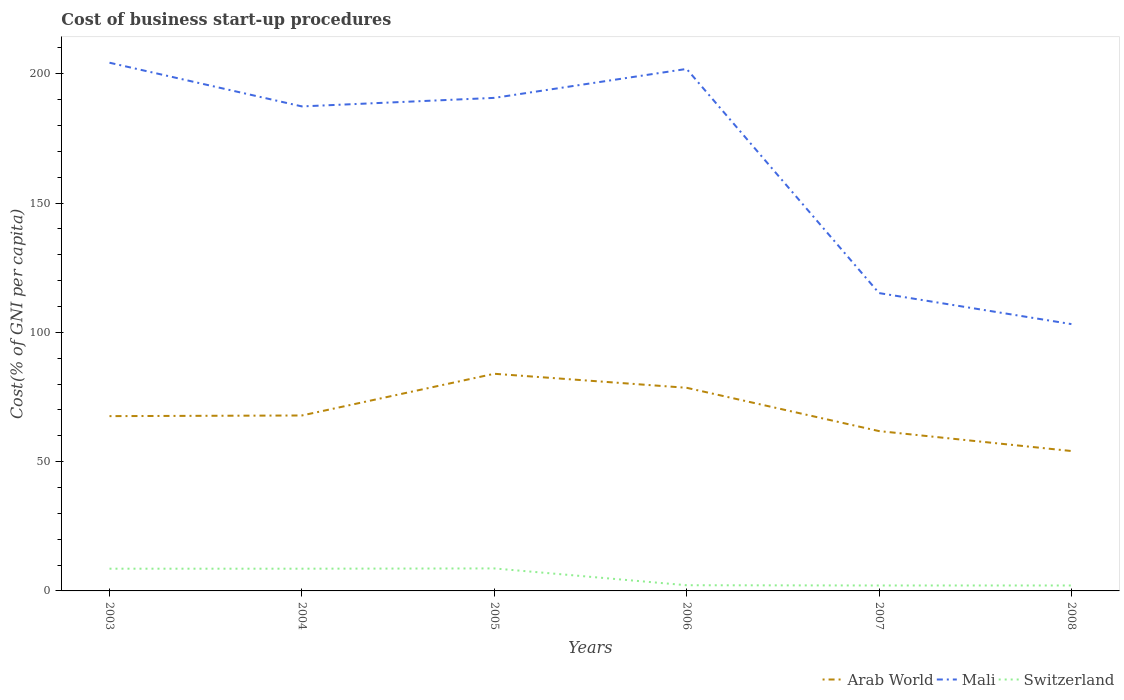How many different coloured lines are there?
Provide a short and direct response. 3. Across all years, what is the maximum cost of business start-up procedures in Arab World?
Give a very brief answer. 54.11. In which year was the cost of business start-up procedures in Arab World maximum?
Your answer should be very brief. 2008. What is the difference between the highest and the second highest cost of business start-up procedures in Switzerland?
Ensure brevity in your answer.  6.6. Is the cost of business start-up procedures in Arab World strictly greater than the cost of business start-up procedures in Mali over the years?
Provide a succinct answer. Yes. How many lines are there?
Provide a short and direct response. 3. Are the values on the major ticks of Y-axis written in scientific E-notation?
Offer a very short reply. No. Does the graph contain any zero values?
Your answer should be compact. No. Does the graph contain grids?
Provide a short and direct response. No. How are the legend labels stacked?
Offer a very short reply. Horizontal. What is the title of the graph?
Your response must be concise. Cost of business start-up procedures. What is the label or title of the Y-axis?
Keep it short and to the point. Cost(% of GNI per capita). What is the Cost(% of GNI per capita) in Arab World in 2003?
Ensure brevity in your answer.  67.61. What is the Cost(% of GNI per capita) in Mali in 2003?
Give a very brief answer. 204.3. What is the Cost(% of GNI per capita) of Switzerland in 2003?
Provide a succinct answer. 8.6. What is the Cost(% of GNI per capita) in Arab World in 2004?
Your response must be concise. 67.86. What is the Cost(% of GNI per capita) in Mali in 2004?
Provide a short and direct response. 187.4. What is the Cost(% of GNI per capita) of Arab World in 2005?
Your response must be concise. 83.99. What is the Cost(% of GNI per capita) of Mali in 2005?
Provide a short and direct response. 190.7. What is the Cost(% of GNI per capita) in Arab World in 2006?
Keep it short and to the point. 78.57. What is the Cost(% of GNI per capita) of Mali in 2006?
Your answer should be compact. 201.9. What is the Cost(% of GNI per capita) in Arab World in 2007?
Provide a succinct answer. 61.82. What is the Cost(% of GNI per capita) in Mali in 2007?
Offer a very short reply. 115.2. What is the Cost(% of GNI per capita) of Arab World in 2008?
Ensure brevity in your answer.  54.11. What is the Cost(% of GNI per capita) of Mali in 2008?
Offer a terse response. 103.2. What is the Cost(% of GNI per capita) in Switzerland in 2008?
Offer a terse response. 2.1. Across all years, what is the maximum Cost(% of GNI per capita) in Arab World?
Make the answer very short. 83.99. Across all years, what is the maximum Cost(% of GNI per capita) of Mali?
Offer a very short reply. 204.3. Across all years, what is the minimum Cost(% of GNI per capita) of Arab World?
Give a very brief answer. 54.11. Across all years, what is the minimum Cost(% of GNI per capita) of Mali?
Ensure brevity in your answer.  103.2. What is the total Cost(% of GNI per capita) of Arab World in the graph?
Offer a very short reply. 413.95. What is the total Cost(% of GNI per capita) in Mali in the graph?
Provide a succinct answer. 1002.7. What is the total Cost(% of GNI per capita) in Switzerland in the graph?
Provide a short and direct response. 32.3. What is the difference between the Cost(% of GNI per capita) in Arab World in 2003 and that in 2004?
Your answer should be very brief. -0.25. What is the difference between the Cost(% of GNI per capita) of Arab World in 2003 and that in 2005?
Provide a short and direct response. -16.38. What is the difference between the Cost(% of GNI per capita) in Arab World in 2003 and that in 2006?
Your answer should be very brief. -10.96. What is the difference between the Cost(% of GNI per capita) in Arab World in 2003 and that in 2007?
Give a very brief answer. 5.79. What is the difference between the Cost(% of GNI per capita) of Mali in 2003 and that in 2007?
Give a very brief answer. 89.1. What is the difference between the Cost(% of GNI per capita) of Switzerland in 2003 and that in 2007?
Provide a succinct answer. 6.5. What is the difference between the Cost(% of GNI per capita) in Arab World in 2003 and that in 2008?
Your answer should be compact. 13.5. What is the difference between the Cost(% of GNI per capita) in Mali in 2003 and that in 2008?
Make the answer very short. 101.1. What is the difference between the Cost(% of GNI per capita) of Arab World in 2004 and that in 2005?
Your answer should be compact. -16.13. What is the difference between the Cost(% of GNI per capita) of Mali in 2004 and that in 2005?
Make the answer very short. -3.3. What is the difference between the Cost(% of GNI per capita) in Switzerland in 2004 and that in 2005?
Make the answer very short. -0.1. What is the difference between the Cost(% of GNI per capita) of Arab World in 2004 and that in 2006?
Keep it short and to the point. -10.71. What is the difference between the Cost(% of GNI per capita) of Arab World in 2004 and that in 2007?
Give a very brief answer. 6.04. What is the difference between the Cost(% of GNI per capita) in Mali in 2004 and that in 2007?
Ensure brevity in your answer.  72.2. What is the difference between the Cost(% of GNI per capita) in Arab World in 2004 and that in 2008?
Keep it short and to the point. 13.75. What is the difference between the Cost(% of GNI per capita) in Mali in 2004 and that in 2008?
Provide a succinct answer. 84.2. What is the difference between the Cost(% of GNI per capita) in Arab World in 2005 and that in 2006?
Provide a succinct answer. 5.42. What is the difference between the Cost(% of GNI per capita) of Mali in 2005 and that in 2006?
Provide a short and direct response. -11.2. What is the difference between the Cost(% of GNI per capita) in Switzerland in 2005 and that in 2006?
Provide a short and direct response. 6.5. What is the difference between the Cost(% of GNI per capita) in Arab World in 2005 and that in 2007?
Keep it short and to the point. 22.17. What is the difference between the Cost(% of GNI per capita) in Mali in 2005 and that in 2007?
Offer a very short reply. 75.5. What is the difference between the Cost(% of GNI per capita) in Switzerland in 2005 and that in 2007?
Make the answer very short. 6.6. What is the difference between the Cost(% of GNI per capita) of Arab World in 2005 and that in 2008?
Make the answer very short. 29.88. What is the difference between the Cost(% of GNI per capita) in Mali in 2005 and that in 2008?
Make the answer very short. 87.5. What is the difference between the Cost(% of GNI per capita) in Arab World in 2006 and that in 2007?
Your answer should be very brief. 16.75. What is the difference between the Cost(% of GNI per capita) of Mali in 2006 and that in 2007?
Provide a short and direct response. 86.7. What is the difference between the Cost(% of GNI per capita) of Switzerland in 2006 and that in 2007?
Your response must be concise. 0.1. What is the difference between the Cost(% of GNI per capita) of Arab World in 2006 and that in 2008?
Your answer should be compact. 24.46. What is the difference between the Cost(% of GNI per capita) of Mali in 2006 and that in 2008?
Your answer should be compact. 98.7. What is the difference between the Cost(% of GNI per capita) in Switzerland in 2006 and that in 2008?
Keep it short and to the point. 0.1. What is the difference between the Cost(% of GNI per capita) in Arab World in 2007 and that in 2008?
Make the answer very short. 7.71. What is the difference between the Cost(% of GNI per capita) of Mali in 2007 and that in 2008?
Your answer should be compact. 12. What is the difference between the Cost(% of GNI per capita) of Switzerland in 2007 and that in 2008?
Make the answer very short. 0. What is the difference between the Cost(% of GNI per capita) of Arab World in 2003 and the Cost(% of GNI per capita) of Mali in 2004?
Offer a terse response. -119.79. What is the difference between the Cost(% of GNI per capita) of Arab World in 2003 and the Cost(% of GNI per capita) of Switzerland in 2004?
Your answer should be compact. 59.01. What is the difference between the Cost(% of GNI per capita) of Mali in 2003 and the Cost(% of GNI per capita) of Switzerland in 2004?
Your response must be concise. 195.7. What is the difference between the Cost(% of GNI per capita) in Arab World in 2003 and the Cost(% of GNI per capita) in Mali in 2005?
Make the answer very short. -123.09. What is the difference between the Cost(% of GNI per capita) of Arab World in 2003 and the Cost(% of GNI per capita) of Switzerland in 2005?
Offer a terse response. 58.91. What is the difference between the Cost(% of GNI per capita) in Mali in 2003 and the Cost(% of GNI per capita) in Switzerland in 2005?
Keep it short and to the point. 195.6. What is the difference between the Cost(% of GNI per capita) in Arab World in 2003 and the Cost(% of GNI per capita) in Mali in 2006?
Your response must be concise. -134.29. What is the difference between the Cost(% of GNI per capita) in Arab World in 2003 and the Cost(% of GNI per capita) in Switzerland in 2006?
Ensure brevity in your answer.  65.41. What is the difference between the Cost(% of GNI per capita) in Mali in 2003 and the Cost(% of GNI per capita) in Switzerland in 2006?
Your answer should be compact. 202.1. What is the difference between the Cost(% of GNI per capita) of Arab World in 2003 and the Cost(% of GNI per capita) of Mali in 2007?
Your answer should be very brief. -47.59. What is the difference between the Cost(% of GNI per capita) in Arab World in 2003 and the Cost(% of GNI per capita) in Switzerland in 2007?
Keep it short and to the point. 65.51. What is the difference between the Cost(% of GNI per capita) of Mali in 2003 and the Cost(% of GNI per capita) of Switzerland in 2007?
Your answer should be very brief. 202.2. What is the difference between the Cost(% of GNI per capita) in Arab World in 2003 and the Cost(% of GNI per capita) in Mali in 2008?
Keep it short and to the point. -35.59. What is the difference between the Cost(% of GNI per capita) in Arab World in 2003 and the Cost(% of GNI per capita) in Switzerland in 2008?
Make the answer very short. 65.51. What is the difference between the Cost(% of GNI per capita) in Mali in 2003 and the Cost(% of GNI per capita) in Switzerland in 2008?
Offer a terse response. 202.2. What is the difference between the Cost(% of GNI per capita) in Arab World in 2004 and the Cost(% of GNI per capita) in Mali in 2005?
Your response must be concise. -122.84. What is the difference between the Cost(% of GNI per capita) in Arab World in 2004 and the Cost(% of GNI per capita) in Switzerland in 2005?
Keep it short and to the point. 59.16. What is the difference between the Cost(% of GNI per capita) of Mali in 2004 and the Cost(% of GNI per capita) of Switzerland in 2005?
Keep it short and to the point. 178.7. What is the difference between the Cost(% of GNI per capita) in Arab World in 2004 and the Cost(% of GNI per capita) in Mali in 2006?
Offer a terse response. -134.04. What is the difference between the Cost(% of GNI per capita) of Arab World in 2004 and the Cost(% of GNI per capita) of Switzerland in 2006?
Offer a very short reply. 65.66. What is the difference between the Cost(% of GNI per capita) in Mali in 2004 and the Cost(% of GNI per capita) in Switzerland in 2006?
Provide a succinct answer. 185.2. What is the difference between the Cost(% of GNI per capita) of Arab World in 2004 and the Cost(% of GNI per capita) of Mali in 2007?
Your response must be concise. -47.34. What is the difference between the Cost(% of GNI per capita) of Arab World in 2004 and the Cost(% of GNI per capita) of Switzerland in 2007?
Provide a succinct answer. 65.76. What is the difference between the Cost(% of GNI per capita) in Mali in 2004 and the Cost(% of GNI per capita) in Switzerland in 2007?
Provide a short and direct response. 185.3. What is the difference between the Cost(% of GNI per capita) of Arab World in 2004 and the Cost(% of GNI per capita) of Mali in 2008?
Give a very brief answer. -35.34. What is the difference between the Cost(% of GNI per capita) in Arab World in 2004 and the Cost(% of GNI per capita) in Switzerland in 2008?
Give a very brief answer. 65.76. What is the difference between the Cost(% of GNI per capita) in Mali in 2004 and the Cost(% of GNI per capita) in Switzerland in 2008?
Offer a very short reply. 185.3. What is the difference between the Cost(% of GNI per capita) of Arab World in 2005 and the Cost(% of GNI per capita) of Mali in 2006?
Offer a terse response. -117.91. What is the difference between the Cost(% of GNI per capita) in Arab World in 2005 and the Cost(% of GNI per capita) in Switzerland in 2006?
Provide a succinct answer. 81.79. What is the difference between the Cost(% of GNI per capita) of Mali in 2005 and the Cost(% of GNI per capita) of Switzerland in 2006?
Offer a terse response. 188.5. What is the difference between the Cost(% of GNI per capita) in Arab World in 2005 and the Cost(% of GNI per capita) in Mali in 2007?
Your answer should be compact. -31.21. What is the difference between the Cost(% of GNI per capita) of Arab World in 2005 and the Cost(% of GNI per capita) of Switzerland in 2007?
Give a very brief answer. 81.89. What is the difference between the Cost(% of GNI per capita) in Mali in 2005 and the Cost(% of GNI per capita) in Switzerland in 2007?
Offer a very short reply. 188.6. What is the difference between the Cost(% of GNI per capita) of Arab World in 2005 and the Cost(% of GNI per capita) of Mali in 2008?
Your answer should be very brief. -19.21. What is the difference between the Cost(% of GNI per capita) in Arab World in 2005 and the Cost(% of GNI per capita) in Switzerland in 2008?
Give a very brief answer. 81.89. What is the difference between the Cost(% of GNI per capita) of Mali in 2005 and the Cost(% of GNI per capita) of Switzerland in 2008?
Offer a very short reply. 188.6. What is the difference between the Cost(% of GNI per capita) in Arab World in 2006 and the Cost(% of GNI per capita) in Mali in 2007?
Offer a very short reply. -36.63. What is the difference between the Cost(% of GNI per capita) in Arab World in 2006 and the Cost(% of GNI per capita) in Switzerland in 2007?
Offer a terse response. 76.47. What is the difference between the Cost(% of GNI per capita) in Mali in 2006 and the Cost(% of GNI per capita) in Switzerland in 2007?
Give a very brief answer. 199.8. What is the difference between the Cost(% of GNI per capita) in Arab World in 2006 and the Cost(% of GNI per capita) in Mali in 2008?
Your answer should be compact. -24.63. What is the difference between the Cost(% of GNI per capita) of Arab World in 2006 and the Cost(% of GNI per capita) of Switzerland in 2008?
Offer a terse response. 76.47. What is the difference between the Cost(% of GNI per capita) in Mali in 2006 and the Cost(% of GNI per capita) in Switzerland in 2008?
Your answer should be compact. 199.8. What is the difference between the Cost(% of GNI per capita) of Arab World in 2007 and the Cost(% of GNI per capita) of Mali in 2008?
Keep it short and to the point. -41.38. What is the difference between the Cost(% of GNI per capita) of Arab World in 2007 and the Cost(% of GNI per capita) of Switzerland in 2008?
Your answer should be very brief. 59.72. What is the difference between the Cost(% of GNI per capita) in Mali in 2007 and the Cost(% of GNI per capita) in Switzerland in 2008?
Offer a very short reply. 113.1. What is the average Cost(% of GNI per capita) in Arab World per year?
Your answer should be compact. 68.99. What is the average Cost(% of GNI per capita) of Mali per year?
Keep it short and to the point. 167.12. What is the average Cost(% of GNI per capita) in Switzerland per year?
Give a very brief answer. 5.38. In the year 2003, what is the difference between the Cost(% of GNI per capita) of Arab World and Cost(% of GNI per capita) of Mali?
Your response must be concise. -136.69. In the year 2003, what is the difference between the Cost(% of GNI per capita) of Arab World and Cost(% of GNI per capita) of Switzerland?
Provide a short and direct response. 59.01. In the year 2003, what is the difference between the Cost(% of GNI per capita) of Mali and Cost(% of GNI per capita) of Switzerland?
Offer a very short reply. 195.7. In the year 2004, what is the difference between the Cost(% of GNI per capita) in Arab World and Cost(% of GNI per capita) in Mali?
Provide a short and direct response. -119.54. In the year 2004, what is the difference between the Cost(% of GNI per capita) in Arab World and Cost(% of GNI per capita) in Switzerland?
Provide a short and direct response. 59.26. In the year 2004, what is the difference between the Cost(% of GNI per capita) in Mali and Cost(% of GNI per capita) in Switzerland?
Your answer should be compact. 178.8. In the year 2005, what is the difference between the Cost(% of GNI per capita) of Arab World and Cost(% of GNI per capita) of Mali?
Offer a very short reply. -106.71. In the year 2005, what is the difference between the Cost(% of GNI per capita) in Arab World and Cost(% of GNI per capita) in Switzerland?
Offer a terse response. 75.29. In the year 2005, what is the difference between the Cost(% of GNI per capita) in Mali and Cost(% of GNI per capita) in Switzerland?
Provide a short and direct response. 182. In the year 2006, what is the difference between the Cost(% of GNI per capita) in Arab World and Cost(% of GNI per capita) in Mali?
Your answer should be very brief. -123.33. In the year 2006, what is the difference between the Cost(% of GNI per capita) in Arab World and Cost(% of GNI per capita) in Switzerland?
Provide a succinct answer. 76.37. In the year 2006, what is the difference between the Cost(% of GNI per capita) in Mali and Cost(% of GNI per capita) in Switzerland?
Ensure brevity in your answer.  199.7. In the year 2007, what is the difference between the Cost(% of GNI per capita) in Arab World and Cost(% of GNI per capita) in Mali?
Offer a very short reply. -53.38. In the year 2007, what is the difference between the Cost(% of GNI per capita) in Arab World and Cost(% of GNI per capita) in Switzerland?
Give a very brief answer. 59.72. In the year 2007, what is the difference between the Cost(% of GNI per capita) of Mali and Cost(% of GNI per capita) of Switzerland?
Give a very brief answer. 113.1. In the year 2008, what is the difference between the Cost(% of GNI per capita) in Arab World and Cost(% of GNI per capita) in Mali?
Ensure brevity in your answer.  -49.09. In the year 2008, what is the difference between the Cost(% of GNI per capita) in Arab World and Cost(% of GNI per capita) in Switzerland?
Offer a very short reply. 52.01. In the year 2008, what is the difference between the Cost(% of GNI per capita) of Mali and Cost(% of GNI per capita) of Switzerland?
Provide a succinct answer. 101.1. What is the ratio of the Cost(% of GNI per capita) of Arab World in 2003 to that in 2004?
Your answer should be compact. 1. What is the ratio of the Cost(% of GNI per capita) of Mali in 2003 to that in 2004?
Your response must be concise. 1.09. What is the ratio of the Cost(% of GNI per capita) in Arab World in 2003 to that in 2005?
Make the answer very short. 0.81. What is the ratio of the Cost(% of GNI per capita) of Mali in 2003 to that in 2005?
Give a very brief answer. 1.07. What is the ratio of the Cost(% of GNI per capita) of Switzerland in 2003 to that in 2005?
Give a very brief answer. 0.99. What is the ratio of the Cost(% of GNI per capita) of Arab World in 2003 to that in 2006?
Give a very brief answer. 0.86. What is the ratio of the Cost(% of GNI per capita) in Mali in 2003 to that in 2006?
Provide a succinct answer. 1.01. What is the ratio of the Cost(% of GNI per capita) in Switzerland in 2003 to that in 2006?
Make the answer very short. 3.91. What is the ratio of the Cost(% of GNI per capita) of Arab World in 2003 to that in 2007?
Ensure brevity in your answer.  1.09. What is the ratio of the Cost(% of GNI per capita) in Mali in 2003 to that in 2007?
Offer a terse response. 1.77. What is the ratio of the Cost(% of GNI per capita) in Switzerland in 2003 to that in 2007?
Provide a short and direct response. 4.1. What is the ratio of the Cost(% of GNI per capita) of Arab World in 2003 to that in 2008?
Provide a succinct answer. 1.25. What is the ratio of the Cost(% of GNI per capita) of Mali in 2003 to that in 2008?
Your answer should be very brief. 1.98. What is the ratio of the Cost(% of GNI per capita) of Switzerland in 2003 to that in 2008?
Offer a very short reply. 4.1. What is the ratio of the Cost(% of GNI per capita) in Arab World in 2004 to that in 2005?
Give a very brief answer. 0.81. What is the ratio of the Cost(% of GNI per capita) in Mali in 2004 to that in 2005?
Give a very brief answer. 0.98. What is the ratio of the Cost(% of GNI per capita) in Switzerland in 2004 to that in 2005?
Offer a very short reply. 0.99. What is the ratio of the Cost(% of GNI per capita) of Arab World in 2004 to that in 2006?
Your response must be concise. 0.86. What is the ratio of the Cost(% of GNI per capita) in Mali in 2004 to that in 2006?
Your response must be concise. 0.93. What is the ratio of the Cost(% of GNI per capita) in Switzerland in 2004 to that in 2006?
Your answer should be compact. 3.91. What is the ratio of the Cost(% of GNI per capita) in Arab World in 2004 to that in 2007?
Your response must be concise. 1.1. What is the ratio of the Cost(% of GNI per capita) of Mali in 2004 to that in 2007?
Your answer should be very brief. 1.63. What is the ratio of the Cost(% of GNI per capita) of Switzerland in 2004 to that in 2007?
Keep it short and to the point. 4.1. What is the ratio of the Cost(% of GNI per capita) in Arab World in 2004 to that in 2008?
Offer a terse response. 1.25. What is the ratio of the Cost(% of GNI per capita) of Mali in 2004 to that in 2008?
Offer a terse response. 1.82. What is the ratio of the Cost(% of GNI per capita) of Switzerland in 2004 to that in 2008?
Your response must be concise. 4.1. What is the ratio of the Cost(% of GNI per capita) in Arab World in 2005 to that in 2006?
Give a very brief answer. 1.07. What is the ratio of the Cost(% of GNI per capita) in Mali in 2005 to that in 2006?
Provide a short and direct response. 0.94. What is the ratio of the Cost(% of GNI per capita) of Switzerland in 2005 to that in 2006?
Offer a very short reply. 3.95. What is the ratio of the Cost(% of GNI per capita) of Arab World in 2005 to that in 2007?
Offer a terse response. 1.36. What is the ratio of the Cost(% of GNI per capita) of Mali in 2005 to that in 2007?
Ensure brevity in your answer.  1.66. What is the ratio of the Cost(% of GNI per capita) of Switzerland in 2005 to that in 2007?
Provide a short and direct response. 4.14. What is the ratio of the Cost(% of GNI per capita) in Arab World in 2005 to that in 2008?
Offer a terse response. 1.55. What is the ratio of the Cost(% of GNI per capita) in Mali in 2005 to that in 2008?
Give a very brief answer. 1.85. What is the ratio of the Cost(% of GNI per capita) of Switzerland in 2005 to that in 2008?
Offer a very short reply. 4.14. What is the ratio of the Cost(% of GNI per capita) in Arab World in 2006 to that in 2007?
Give a very brief answer. 1.27. What is the ratio of the Cost(% of GNI per capita) in Mali in 2006 to that in 2007?
Provide a short and direct response. 1.75. What is the ratio of the Cost(% of GNI per capita) in Switzerland in 2006 to that in 2007?
Provide a short and direct response. 1.05. What is the ratio of the Cost(% of GNI per capita) in Arab World in 2006 to that in 2008?
Provide a succinct answer. 1.45. What is the ratio of the Cost(% of GNI per capita) of Mali in 2006 to that in 2008?
Offer a very short reply. 1.96. What is the ratio of the Cost(% of GNI per capita) in Switzerland in 2006 to that in 2008?
Offer a terse response. 1.05. What is the ratio of the Cost(% of GNI per capita) of Arab World in 2007 to that in 2008?
Make the answer very short. 1.14. What is the ratio of the Cost(% of GNI per capita) in Mali in 2007 to that in 2008?
Keep it short and to the point. 1.12. What is the ratio of the Cost(% of GNI per capita) of Switzerland in 2007 to that in 2008?
Your answer should be compact. 1. What is the difference between the highest and the second highest Cost(% of GNI per capita) in Arab World?
Provide a succinct answer. 5.42. What is the difference between the highest and the second highest Cost(% of GNI per capita) in Mali?
Provide a succinct answer. 2.4. What is the difference between the highest and the second highest Cost(% of GNI per capita) in Switzerland?
Ensure brevity in your answer.  0.1. What is the difference between the highest and the lowest Cost(% of GNI per capita) in Arab World?
Keep it short and to the point. 29.88. What is the difference between the highest and the lowest Cost(% of GNI per capita) of Mali?
Offer a terse response. 101.1. 